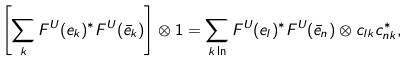Convert formula to latex. <formula><loc_0><loc_0><loc_500><loc_500>\left [ \sum _ { k } F ^ { U } ( e _ { k } ) { ^ { * } } F ^ { U } ( \bar { e } _ { k } ) \right ] \otimes 1 = \sum _ { k \ln } F ^ { U } ( e _ { l } ) { ^ { * } } F ^ { U } ( \bar { e } _ { n } ) \otimes c _ { l k } c _ { n k } ^ { * } ,</formula> 